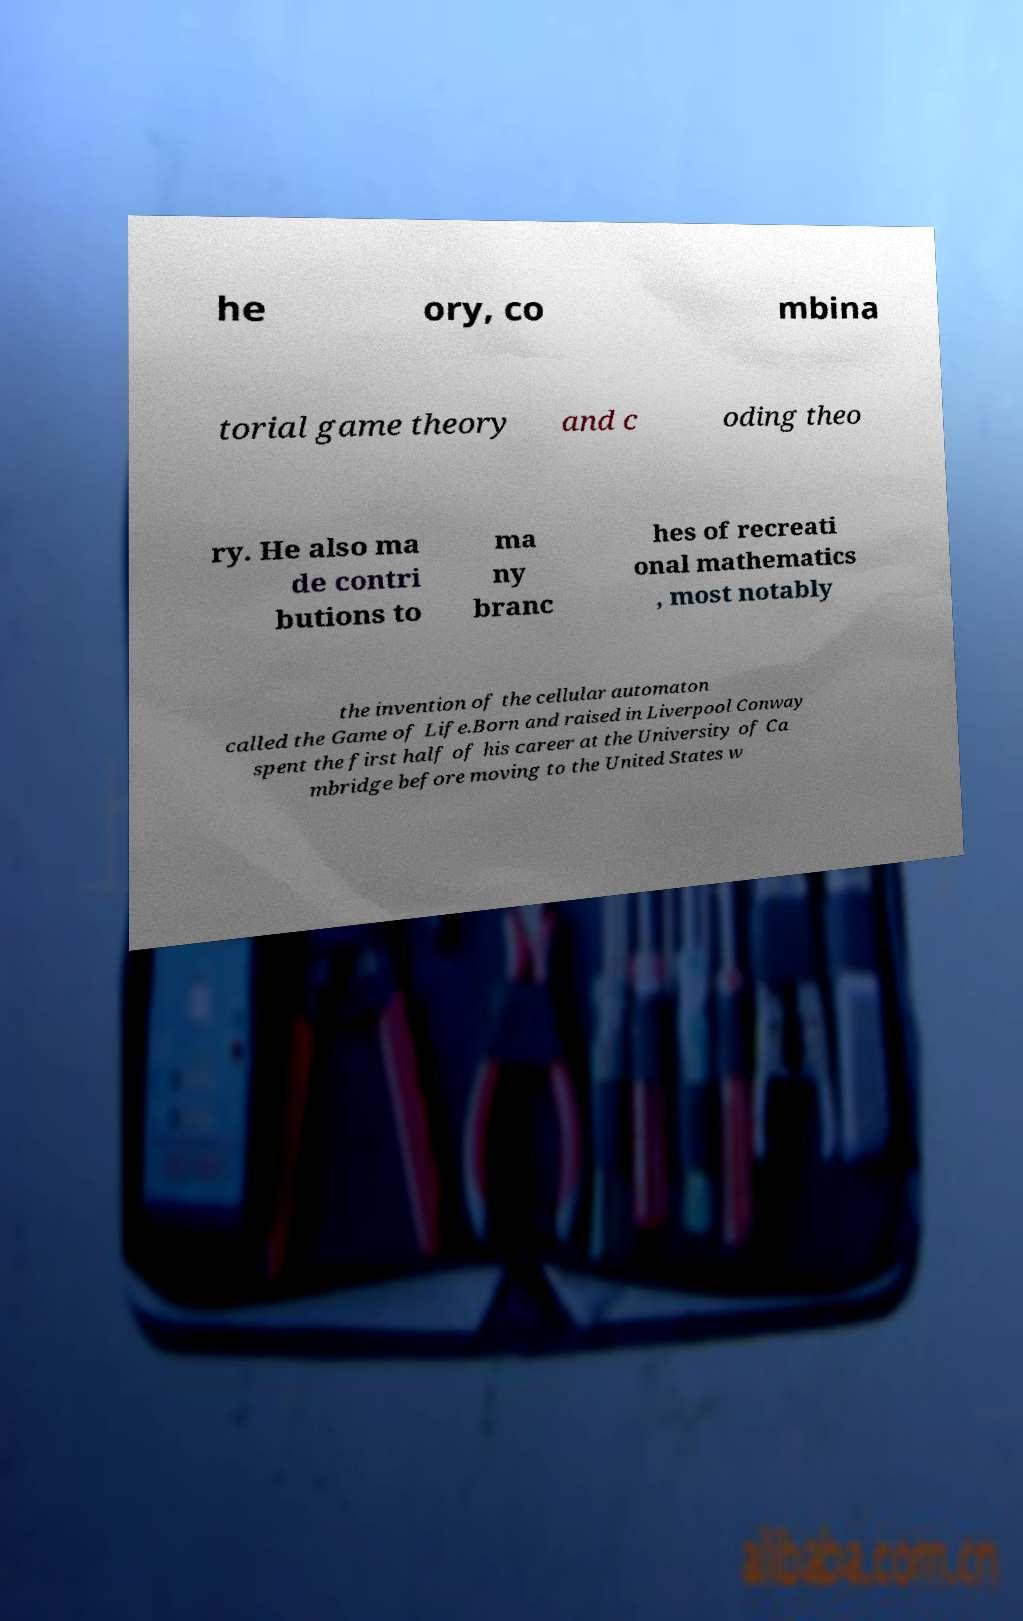There's text embedded in this image that I need extracted. Can you transcribe it verbatim? he ory, co mbina torial game theory and c oding theo ry. He also ma de contri butions to ma ny branc hes of recreati onal mathematics , most notably the invention of the cellular automaton called the Game of Life.Born and raised in Liverpool Conway spent the first half of his career at the University of Ca mbridge before moving to the United States w 